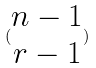<formula> <loc_0><loc_0><loc_500><loc_500>( \begin{matrix} n - 1 \\ r - 1 \end{matrix} )</formula> 